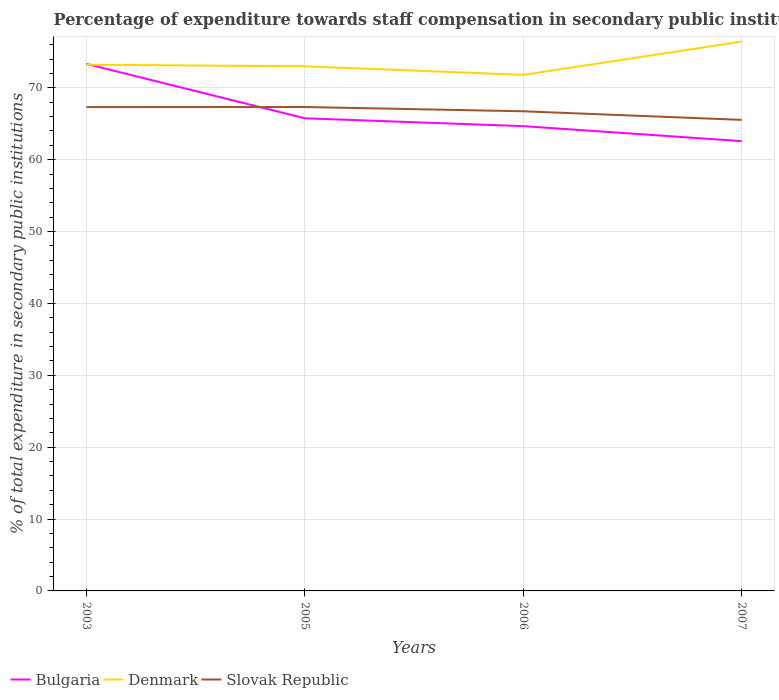Does the line corresponding to Slovak Republic intersect with the line corresponding to Bulgaria?
Offer a terse response. Yes. Is the number of lines equal to the number of legend labels?
Your answer should be compact. Yes. Across all years, what is the maximum percentage of expenditure towards staff compensation in Bulgaria?
Give a very brief answer. 62.57. What is the total percentage of expenditure towards staff compensation in Slovak Republic in the graph?
Your answer should be very brief. 1.19. What is the difference between the highest and the second highest percentage of expenditure towards staff compensation in Slovak Republic?
Ensure brevity in your answer.  1.79. What is the difference between two consecutive major ticks on the Y-axis?
Offer a terse response. 10. Does the graph contain grids?
Make the answer very short. Yes. Where does the legend appear in the graph?
Your answer should be very brief. Bottom left. How many legend labels are there?
Make the answer very short. 3. What is the title of the graph?
Keep it short and to the point. Percentage of expenditure towards staff compensation in secondary public institutions. Does "Arab World" appear as one of the legend labels in the graph?
Ensure brevity in your answer.  No. What is the label or title of the X-axis?
Offer a very short reply. Years. What is the label or title of the Y-axis?
Ensure brevity in your answer.  % of total expenditure in secondary public institutions. What is the % of total expenditure in secondary public institutions in Bulgaria in 2003?
Give a very brief answer. 73.32. What is the % of total expenditure in secondary public institutions in Denmark in 2003?
Keep it short and to the point. 73.21. What is the % of total expenditure in secondary public institutions of Slovak Republic in 2003?
Keep it short and to the point. 67.31. What is the % of total expenditure in secondary public institutions of Bulgaria in 2005?
Your answer should be compact. 65.75. What is the % of total expenditure in secondary public institutions of Denmark in 2005?
Your answer should be compact. 72.99. What is the % of total expenditure in secondary public institutions in Slovak Republic in 2005?
Provide a short and direct response. 67.32. What is the % of total expenditure in secondary public institutions of Bulgaria in 2006?
Your answer should be compact. 64.66. What is the % of total expenditure in secondary public institutions in Denmark in 2006?
Offer a very short reply. 71.79. What is the % of total expenditure in secondary public institutions in Slovak Republic in 2006?
Keep it short and to the point. 66.73. What is the % of total expenditure in secondary public institutions of Bulgaria in 2007?
Make the answer very short. 62.57. What is the % of total expenditure in secondary public institutions in Denmark in 2007?
Make the answer very short. 76.43. What is the % of total expenditure in secondary public institutions in Slovak Republic in 2007?
Provide a succinct answer. 65.53. Across all years, what is the maximum % of total expenditure in secondary public institutions in Bulgaria?
Your answer should be very brief. 73.32. Across all years, what is the maximum % of total expenditure in secondary public institutions of Denmark?
Offer a terse response. 76.43. Across all years, what is the maximum % of total expenditure in secondary public institutions of Slovak Republic?
Make the answer very short. 67.32. Across all years, what is the minimum % of total expenditure in secondary public institutions in Bulgaria?
Make the answer very short. 62.57. Across all years, what is the minimum % of total expenditure in secondary public institutions in Denmark?
Provide a succinct answer. 71.79. Across all years, what is the minimum % of total expenditure in secondary public institutions of Slovak Republic?
Give a very brief answer. 65.53. What is the total % of total expenditure in secondary public institutions in Bulgaria in the graph?
Keep it short and to the point. 266.31. What is the total % of total expenditure in secondary public institutions in Denmark in the graph?
Offer a terse response. 294.42. What is the total % of total expenditure in secondary public institutions in Slovak Republic in the graph?
Your answer should be very brief. 266.9. What is the difference between the % of total expenditure in secondary public institutions of Bulgaria in 2003 and that in 2005?
Keep it short and to the point. 7.57. What is the difference between the % of total expenditure in secondary public institutions of Denmark in 2003 and that in 2005?
Give a very brief answer. 0.23. What is the difference between the % of total expenditure in secondary public institutions in Slovak Republic in 2003 and that in 2005?
Offer a terse response. -0.01. What is the difference between the % of total expenditure in secondary public institutions in Bulgaria in 2003 and that in 2006?
Your response must be concise. 8.66. What is the difference between the % of total expenditure in secondary public institutions of Denmark in 2003 and that in 2006?
Offer a terse response. 1.42. What is the difference between the % of total expenditure in secondary public institutions of Slovak Republic in 2003 and that in 2006?
Your answer should be compact. 0.58. What is the difference between the % of total expenditure in secondary public institutions of Bulgaria in 2003 and that in 2007?
Offer a very short reply. 10.75. What is the difference between the % of total expenditure in secondary public institutions in Denmark in 2003 and that in 2007?
Offer a terse response. -3.22. What is the difference between the % of total expenditure in secondary public institutions in Slovak Republic in 2003 and that in 2007?
Offer a terse response. 1.78. What is the difference between the % of total expenditure in secondary public institutions of Bulgaria in 2005 and that in 2006?
Keep it short and to the point. 1.09. What is the difference between the % of total expenditure in secondary public institutions in Denmark in 2005 and that in 2006?
Your answer should be compact. 1.19. What is the difference between the % of total expenditure in secondary public institutions in Slovak Republic in 2005 and that in 2006?
Your response must be concise. 0.59. What is the difference between the % of total expenditure in secondary public institutions of Bulgaria in 2005 and that in 2007?
Your answer should be compact. 3.18. What is the difference between the % of total expenditure in secondary public institutions in Denmark in 2005 and that in 2007?
Your answer should be very brief. -3.44. What is the difference between the % of total expenditure in secondary public institutions of Slovak Republic in 2005 and that in 2007?
Ensure brevity in your answer.  1.79. What is the difference between the % of total expenditure in secondary public institutions in Bulgaria in 2006 and that in 2007?
Your answer should be compact. 2.09. What is the difference between the % of total expenditure in secondary public institutions in Denmark in 2006 and that in 2007?
Keep it short and to the point. -4.64. What is the difference between the % of total expenditure in secondary public institutions in Slovak Republic in 2006 and that in 2007?
Keep it short and to the point. 1.19. What is the difference between the % of total expenditure in secondary public institutions in Bulgaria in 2003 and the % of total expenditure in secondary public institutions in Denmark in 2005?
Offer a very short reply. 0.34. What is the difference between the % of total expenditure in secondary public institutions of Bulgaria in 2003 and the % of total expenditure in secondary public institutions of Slovak Republic in 2005?
Your answer should be compact. 6. What is the difference between the % of total expenditure in secondary public institutions of Denmark in 2003 and the % of total expenditure in secondary public institutions of Slovak Republic in 2005?
Offer a very short reply. 5.89. What is the difference between the % of total expenditure in secondary public institutions of Bulgaria in 2003 and the % of total expenditure in secondary public institutions of Denmark in 2006?
Give a very brief answer. 1.53. What is the difference between the % of total expenditure in secondary public institutions of Bulgaria in 2003 and the % of total expenditure in secondary public institutions of Slovak Republic in 2006?
Make the answer very short. 6.59. What is the difference between the % of total expenditure in secondary public institutions of Denmark in 2003 and the % of total expenditure in secondary public institutions of Slovak Republic in 2006?
Keep it short and to the point. 6.48. What is the difference between the % of total expenditure in secondary public institutions in Bulgaria in 2003 and the % of total expenditure in secondary public institutions in Denmark in 2007?
Provide a succinct answer. -3.11. What is the difference between the % of total expenditure in secondary public institutions in Bulgaria in 2003 and the % of total expenditure in secondary public institutions in Slovak Republic in 2007?
Give a very brief answer. 7.79. What is the difference between the % of total expenditure in secondary public institutions of Denmark in 2003 and the % of total expenditure in secondary public institutions of Slovak Republic in 2007?
Provide a short and direct response. 7.68. What is the difference between the % of total expenditure in secondary public institutions in Bulgaria in 2005 and the % of total expenditure in secondary public institutions in Denmark in 2006?
Your answer should be very brief. -6.04. What is the difference between the % of total expenditure in secondary public institutions in Bulgaria in 2005 and the % of total expenditure in secondary public institutions in Slovak Republic in 2006?
Ensure brevity in your answer.  -0.97. What is the difference between the % of total expenditure in secondary public institutions in Denmark in 2005 and the % of total expenditure in secondary public institutions in Slovak Republic in 2006?
Your answer should be very brief. 6.26. What is the difference between the % of total expenditure in secondary public institutions of Bulgaria in 2005 and the % of total expenditure in secondary public institutions of Denmark in 2007?
Offer a terse response. -10.68. What is the difference between the % of total expenditure in secondary public institutions in Bulgaria in 2005 and the % of total expenditure in secondary public institutions in Slovak Republic in 2007?
Your answer should be very brief. 0.22. What is the difference between the % of total expenditure in secondary public institutions in Denmark in 2005 and the % of total expenditure in secondary public institutions in Slovak Republic in 2007?
Your answer should be very brief. 7.45. What is the difference between the % of total expenditure in secondary public institutions in Bulgaria in 2006 and the % of total expenditure in secondary public institutions in Denmark in 2007?
Your answer should be very brief. -11.77. What is the difference between the % of total expenditure in secondary public institutions in Bulgaria in 2006 and the % of total expenditure in secondary public institutions in Slovak Republic in 2007?
Your answer should be very brief. -0.87. What is the difference between the % of total expenditure in secondary public institutions of Denmark in 2006 and the % of total expenditure in secondary public institutions of Slovak Republic in 2007?
Your answer should be very brief. 6.26. What is the average % of total expenditure in secondary public institutions of Bulgaria per year?
Offer a very short reply. 66.58. What is the average % of total expenditure in secondary public institutions of Denmark per year?
Offer a terse response. 73.61. What is the average % of total expenditure in secondary public institutions in Slovak Republic per year?
Make the answer very short. 66.72. In the year 2003, what is the difference between the % of total expenditure in secondary public institutions of Bulgaria and % of total expenditure in secondary public institutions of Denmark?
Keep it short and to the point. 0.11. In the year 2003, what is the difference between the % of total expenditure in secondary public institutions of Bulgaria and % of total expenditure in secondary public institutions of Slovak Republic?
Your response must be concise. 6.01. In the year 2003, what is the difference between the % of total expenditure in secondary public institutions of Denmark and % of total expenditure in secondary public institutions of Slovak Republic?
Offer a terse response. 5.9. In the year 2005, what is the difference between the % of total expenditure in secondary public institutions in Bulgaria and % of total expenditure in secondary public institutions in Denmark?
Make the answer very short. -7.23. In the year 2005, what is the difference between the % of total expenditure in secondary public institutions in Bulgaria and % of total expenditure in secondary public institutions in Slovak Republic?
Ensure brevity in your answer.  -1.57. In the year 2005, what is the difference between the % of total expenditure in secondary public institutions in Denmark and % of total expenditure in secondary public institutions in Slovak Republic?
Provide a succinct answer. 5.66. In the year 2006, what is the difference between the % of total expenditure in secondary public institutions of Bulgaria and % of total expenditure in secondary public institutions of Denmark?
Provide a succinct answer. -7.13. In the year 2006, what is the difference between the % of total expenditure in secondary public institutions of Bulgaria and % of total expenditure in secondary public institutions of Slovak Republic?
Provide a short and direct response. -2.07. In the year 2006, what is the difference between the % of total expenditure in secondary public institutions in Denmark and % of total expenditure in secondary public institutions in Slovak Republic?
Provide a short and direct response. 5.07. In the year 2007, what is the difference between the % of total expenditure in secondary public institutions in Bulgaria and % of total expenditure in secondary public institutions in Denmark?
Your response must be concise. -13.86. In the year 2007, what is the difference between the % of total expenditure in secondary public institutions of Bulgaria and % of total expenditure in secondary public institutions of Slovak Republic?
Offer a very short reply. -2.96. In the year 2007, what is the difference between the % of total expenditure in secondary public institutions of Denmark and % of total expenditure in secondary public institutions of Slovak Republic?
Give a very brief answer. 10.9. What is the ratio of the % of total expenditure in secondary public institutions in Bulgaria in 2003 to that in 2005?
Your answer should be compact. 1.12. What is the ratio of the % of total expenditure in secondary public institutions in Denmark in 2003 to that in 2005?
Your response must be concise. 1. What is the ratio of the % of total expenditure in secondary public institutions in Slovak Republic in 2003 to that in 2005?
Give a very brief answer. 1. What is the ratio of the % of total expenditure in secondary public institutions in Bulgaria in 2003 to that in 2006?
Your answer should be very brief. 1.13. What is the ratio of the % of total expenditure in secondary public institutions in Denmark in 2003 to that in 2006?
Provide a succinct answer. 1.02. What is the ratio of the % of total expenditure in secondary public institutions of Slovak Republic in 2003 to that in 2006?
Keep it short and to the point. 1.01. What is the ratio of the % of total expenditure in secondary public institutions of Bulgaria in 2003 to that in 2007?
Provide a short and direct response. 1.17. What is the ratio of the % of total expenditure in secondary public institutions in Denmark in 2003 to that in 2007?
Make the answer very short. 0.96. What is the ratio of the % of total expenditure in secondary public institutions in Slovak Republic in 2003 to that in 2007?
Provide a short and direct response. 1.03. What is the ratio of the % of total expenditure in secondary public institutions in Bulgaria in 2005 to that in 2006?
Offer a very short reply. 1.02. What is the ratio of the % of total expenditure in secondary public institutions in Denmark in 2005 to that in 2006?
Your answer should be very brief. 1.02. What is the ratio of the % of total expenditure in secondary public institutions in Slovak Republic in 2005 to that in 2006?
Your answer should be compact. 1.01. What is the ratio of the % of total expenditure in secondary public institutions in Bulgaria in 2005 to that in 2007?
Ensure brevity in your answer.  1.05. What is the ratio of the % of total expenditure in secondary public institutions in Denmark in 2005 to that in 2007?
Ensure brevity in your answer.  0.95. What is the ratio of the % of total expenditure in secondary public institutions in Slovak Republic in 2005 to that in 2007?
Give a very brief answer. 1.03. What is the ratio of the % of total expenditure in secondary public institutions of Bulgaria in 2006 to that in 2007?
Your answer should be compact. 1.03. What is the ratio of the % of total expenditure in secondary public institutions in Denmark in 2006 to that in 2007?
Keep it short and to the point. 0.94. What is the ratio of the % of total expenditure in secondary public institutions of Slovak Republic in 2006 to that in 2007?
Your answer should be very brief. 1.02. What is the difference between the highest and the second highest % of total expenditure in secondary public institutions in Bulgaria?
Your response must be concise. 7.57. What is the difference between the highest and the second highest % of total expenditure in secondary public institutions of Denmark?
Give a very brief answer. 3.22. What is the difference between the highest and the second highest % of total expenditure in secondary public institutions of Slovak Republic?
Offer a terse response. 0.01. What is the difference between the highest and the lowest % of total expenditure in secondary public institutions in Bulgaria?
Your response must be concise. 10.75. What is the difference between the highest and the lowest % of total expenditure in secondary public institutions in Denmark?
Make the answer very short. 4.64. What is the difference between the highest and the lowest % of total expenditure in secondary public institutions in Slovak Republic?
Offer a terse response. 1.79. 